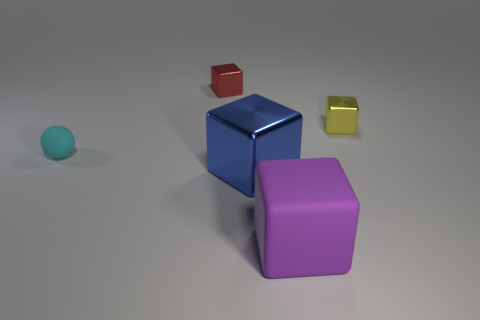Subtract all blue blocks. How many blocks are left? 3 Add 3 yellow spheres. How many objects exist? 8 Subtract all purple cubes. How many cubes are left? 3 Subtract all balls. How many objects are left? 4 Subtract all blue cubes. Subtract all red cylinders. How many cubes are left? 3 Subtract all gray cylinders. How many purple blocks are left? 1 Subtract all big blue rubber cylinders. Subtract all blue blocks. How many objects are left? 4 Add 2 big purple objects. How many big purple objects are left? 3 Add 1 small things. How many small things exist? 4 Subtract 0 cyan cubes. How many objects are left? 5 